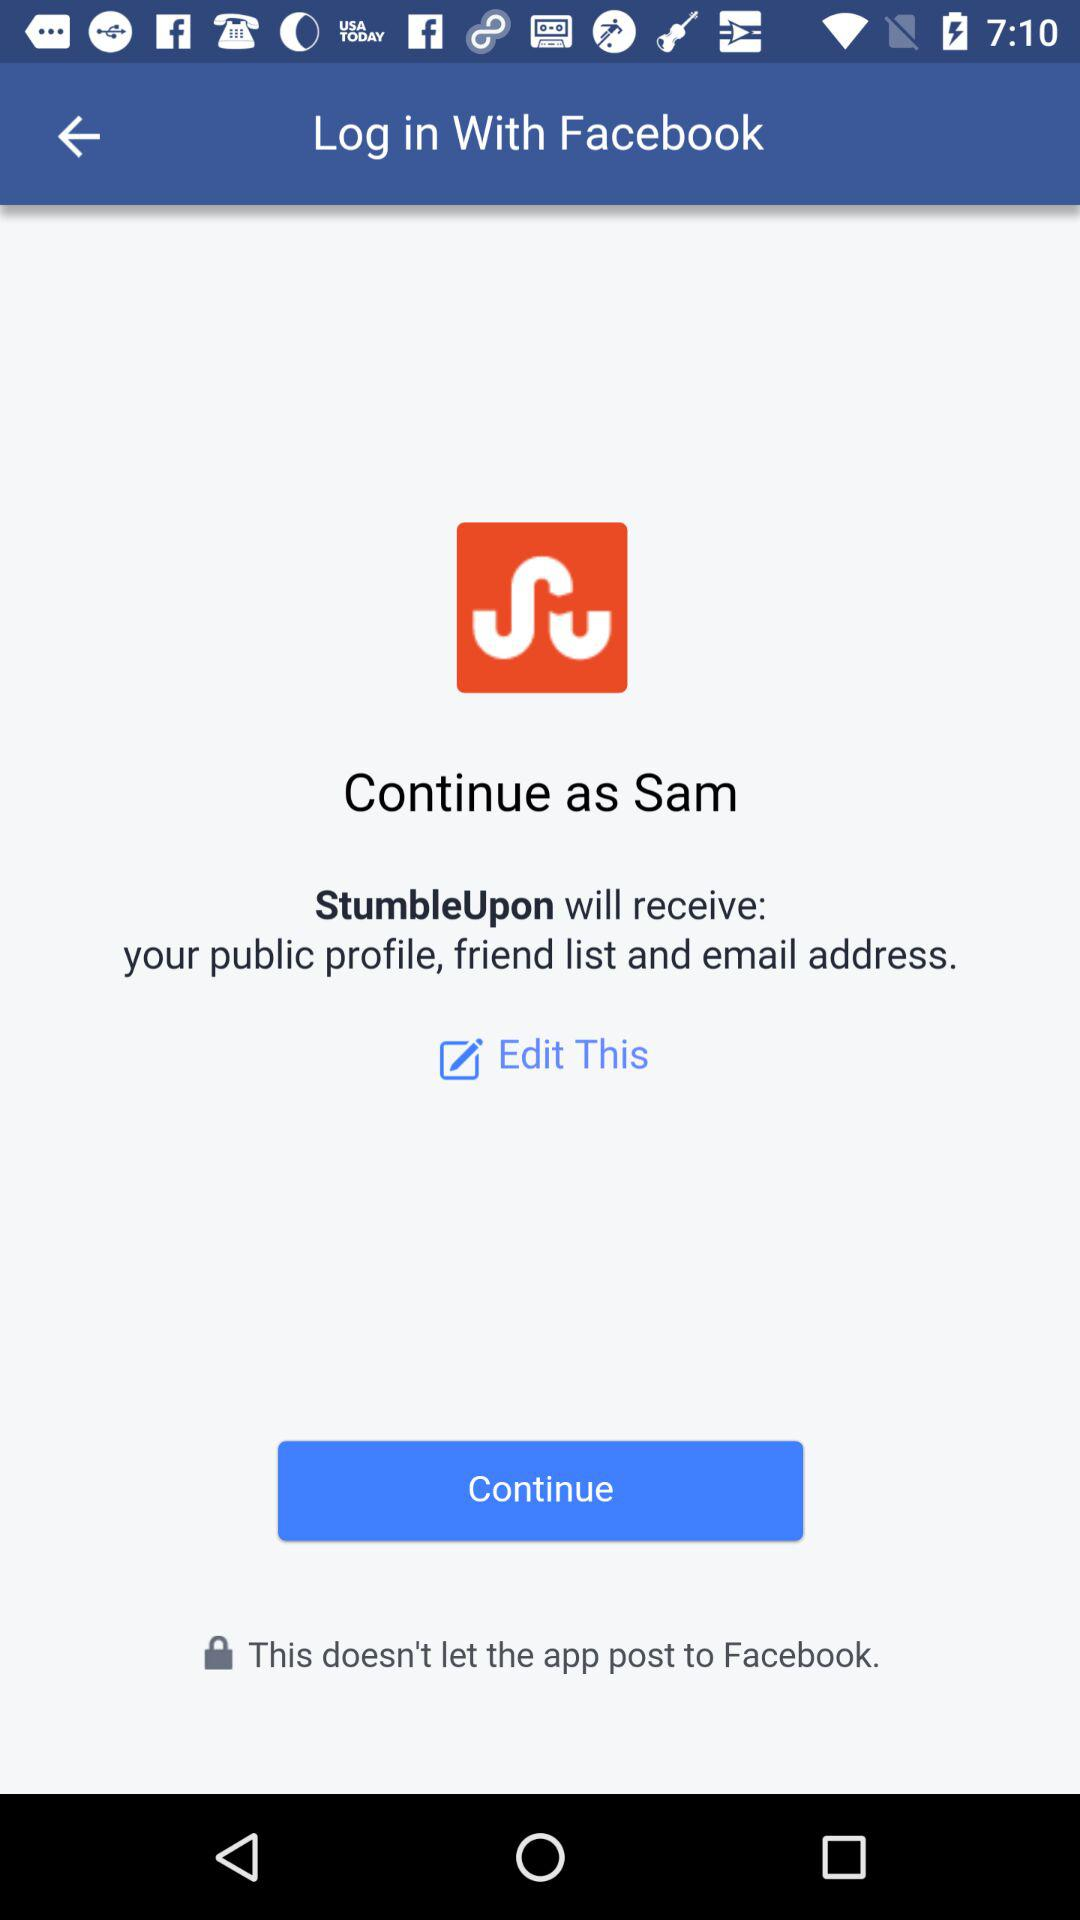What application will receive your public profile, friend list and email address? The application is "StumbleUpon". 